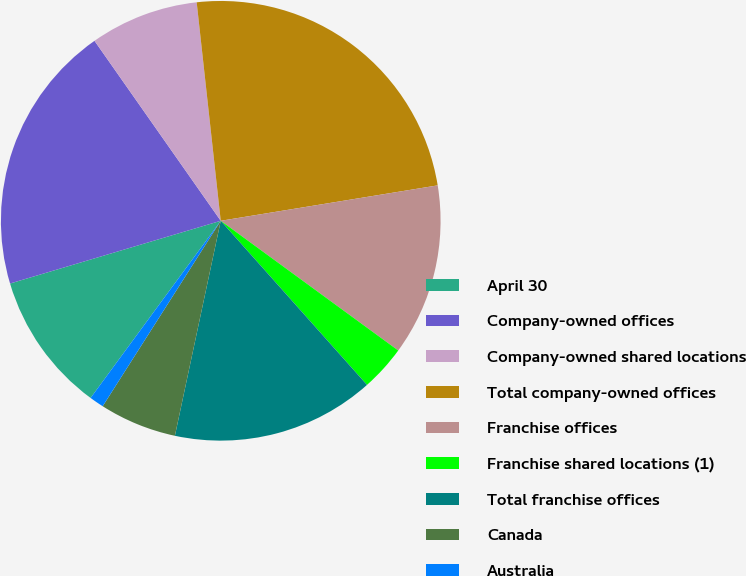Convert chart to OTSL. <chart><loc_0><loc_0><loc_500><loc_500><pie_chart><fcel>April 30<fcel>Company-owned offices<fcel>Company-owned shared locations<fcel>Total company-owned offices<fcel>Franchise offices<fcel>Franchise shared locations (1)<fcel>Total franchise offices<fcel>Canada<fcel>Australia<nl><fcel>10.31%<fcel>19.87%<fcel>7.99%<fcel>24.17%<fcel>12.62%<fcel>3.37%<fcel>14.93%<fcel>5.68%<fcel>1.06%<nl></chart> 